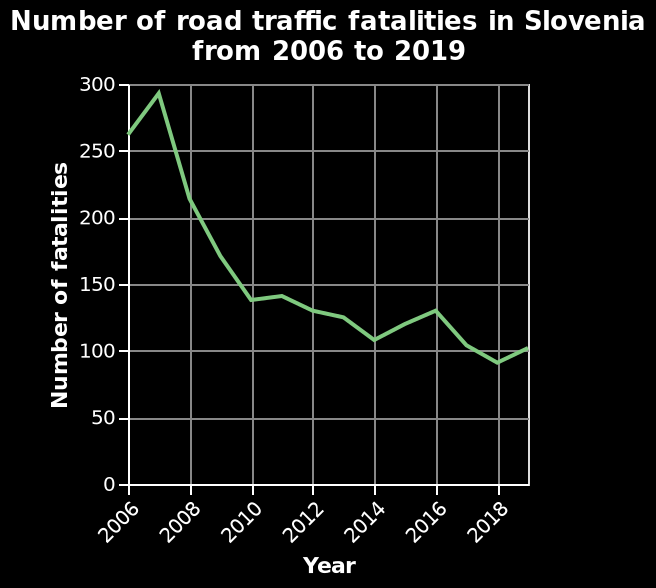<image>
What was the total number of fatalities in the year 2018? The description does not provide the actual number of fatalities in the year 2018. In which year did the data collection for the line plot end? The data collection for the line plot ended in the year 2019. What is the range of the x-axis in the line plot? The range of the x-axis in the line plot is from 2006 to 2018. Is the range of the x-axis in the line plot from 2018 to 2006? No.The range of the x-axis in the line plot is from 2006 to 2018. 